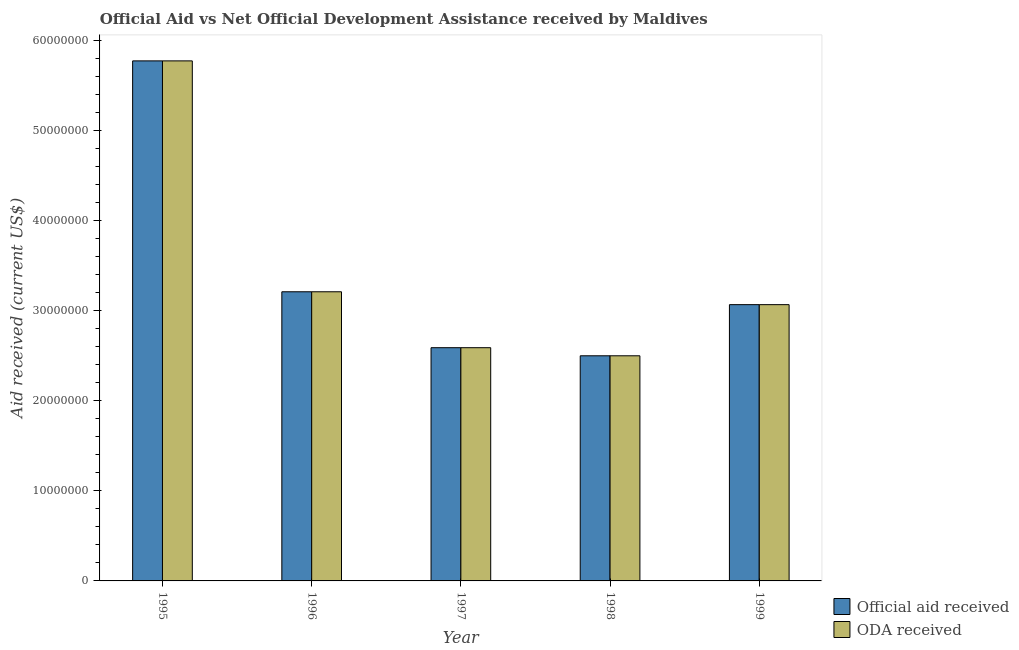How many groups of bars are there?
Offer a very short reply. 5. How many bars are there on the 3rd tick from the left?
Your answer should be compact. 2. What is the official aid received in 1995?
Keep it short and to the point. 5.78e+07. Across all years, what is the maximum oda received?
Give a very brief answer. 5.78e+07. Across all years, what is the minimum oda received?
Your answer should be compact. 2.50e+07. In which year was the oda received maximum?
Give a very brief answer. 1995. In which year was the oda received minimum?
Ensure brevity in your answer.  1998. What is the total oda received in the graph?
Give a very brief answer. 1.71e+08. What is the difference between the oda received in 1997 and that in 1998?
Your response must be concise. 9.00e+05. What is the difference between the official aid received in 1998 and the oda received in 1999?
Provide a short and direct response. -5.68e+06. What is the average oda received per year?
Provide a succinct answer. 3.43e+07. In the year 1999, what is the difference between the official aid received and oda received?
Offer a very short reply. 0. In how many years, is the oda received greater than 56000000 US$?
Ensure brevity in your answer.  1. What is the ratio of the official aid received in 1995 to that in 1997?
Keep it short and to the point. 2.23. Is the oda received in 1998 less than that in 1999?
Keep it short and to the point. Yes. What is the difference between the highest and the second highest official aid received?
Give a very brief answer. 2.56e+07. What is the difference between the highest and the lowest oda received?
Keep it short and to the point. 3.28e+07. In how many years, is the oda received greater than the average oda received taken over all years?
Keep it short and to the point. 1. What does the 2nd bar from the left in 1998 represents?
Offer a very short reply. ODA received. What does the 1st bar from the right in 1996 represents?
Make the answer very short. ODA received. How many bars are there?
Offer a very short reply. 10. Are the values on the major ticks of Y-axis written in scientific E-notation?
Keep it short and to the point. No. What is the title of the graph?
Your response must be concise. Official Aid vs Net Official Development Assistance received by Maldives . Does "Savings" appear as one of the legend labels in the graph?
Ensure brevity in your answer.  No. What is the label or title of the X-axis?
Your answer should be compact. Year. What is the label or title of the Y-axis?
Ensure brevity in your answer.  Aid received (current US$). What is the Aid received (current US$) of Official aid received in 1995?
Offer a terse response. 5.78e+07. What is the Aid received (current US$) in ODA received in 1995?
Your answer should be very brief. 5.78e+07. What is the Aid received (current US$) in Official aid received in 1996?
Provide a short and direct response. 3.21e+07. What is the Aid received (current US$) in ODA received in 1996?
Provide a short and direct response. 3.21e+07. What is the Aid received (current US$) of Official aid received in 1997?
Ensure brevity in your answer.  2.59e+07. What is the Aid received (current US$) in ODA received in 1997?
Your answer should be compact. 2.59e+07. What is the Aid received (current US$) in Official aid received in 1998?
Make the answer very short. 2.50e+07. What is the Aid received (current US$) of ODA received in 1998?
Provide a succinct answer. 2.50e+07. What is the Aid received (current US$) in Official aid received in 1999?
Your response must be concise. 3.07e+07. What is the Aid received (current US$) of ODA received in 1999?
Your answer should be very brief. 3.07e+07. Across all years, what is the maximum Aid received (current US$) in Official aid received?
Provide a short and direct response. 5.78e+07. Across all years, what is the maximum Aid received (current US$) in ODA received?
Make the answer very short. 5.78e+07. Across all years, what is the minimum Aid received (current US$) of Official aid received?
Your answer should be very brief. 2.50e+07. Across all years, what is the minimum Aid received (current US$) in ODA received?
Provide a short and direct response. 2.50e+07. What is the total Aid received (current US$) in Official aid received in the graph?
Keep it short and to the point. 1.71e+08. What is the total Aid received (current US$) of ODA received in the graph?
Provide a succinct answer. 1.71e+08. What is the difference between the Aid received (current US$) in Official aid received in 1995 and that in 1996?
Provide a succinct answer. 2.56e+07. What is the difference between the Aid received (current US$) of ODA received in 1995 and that in 1996?
Ensure brevity in your answer.  2.56e+07. What is the difference between the Aid received (current US$) in Official aid received in 1995 and that in 1997?
Offer a very short reply. 3.18e+07. What is the difference between the Aid received (current US$) in ODA received in 1995 and that in 1997?
Provide a short and direct response. 3.18e+07. What is the difference between the Aid received (current US$) in Official aid received in 1995 and that in 1998?
Provide a short and direct response. 3.28e+07. What is the difference between the Aid received (current US$) of ODA received in 1995 and that in 1998?
Offer a very short reply. 3.28e+07. What is the difference between the Aid received (current US$) in Official aid received in 1995 and that in 1999?
Your answer should be very brief. 2.71e+07. What is the difference between the Aid received (current US$) in ODA received in 1995 and that in 1999?
Make the answer very short. 2.71e+07. What is the difference between the Aid received (current US$) in Official aid received in 1996 and that in 1997?
Make the answer very short. 6.21e+06. What is the difference between the Aid received (current US$) of ODA received in 1996 and that in 1997?
Keep it short and to the point. 6.21e+06. What is the difference between the Aid received (current US$) in Official aid received in 1996 and that in 1998?
Give a very brief answer. 7.11e+06. What is the difference between the Aid received (current US$) in ODA received in 1996 and that in 1998?
Ensure brevity in your answer.  7.11e+06. What is the difference between the Aid received (current US$) of Official aid received in 1996 and that in 1999?
Give a very brief answer. 1.43e+06. What is the difference between the Aid received (current US$) of ODA received in 1996 and that in 1999?
Your response must be concise. 1.43e+06. What is the difference between the Aid received (current US$) of Official aid received in 1997 and that in 1998?
Your answer should be compact. 9.00e+05. What is the difference between the Aid received (current US$) of ODA received in 1997 and that in 1998?
Your answer should be compact. 9.00e+05. What is the difference between the Aid received (current US$) of Official aid received in 1997 and that in 1999?
Provide a succinct answer. -4.78e+06. What is the difference between the Aid received (current US$) of ODA received in 1997 and that in 1999?
Ensure brevity in your answer.  -4.78e+06. What is the difference between the Aid received (current US$) of Official aid received in 1998 and that in 1999?
Provide a succinct answer. -5.68e+06. What is the difference between the Aid received (current US$) of ODA received in 1998 and that in 1999?
Provide a short and direct response. -5.68e+06. What is the difference between the Aid received (current US$) in Official aid received in 1995 and the Aid received (current US$) in ODA received in 1996?
Make the answer very short. 2.56e+07. What is the difference between the Aid received (current US$) in Official aid received in 1995 and the Aid received (current US$) in ODA received in 1997?
Keep it short and to the point. 3.18e+07. What is the difference between the Aid received (current US$) in Official aid received in 1995 and the Aid received (current US$) in ODA received in 1998?
Provide a succinct answer. 3.28e+07. What is the difference between the Aid received (current US$) of Official aid received in 1995 and the Aid received (current US$) of ODA received in 1999?
Offer a very short reply. 2.71e+07. What is the difference between the Aid received (current US$) of Official aid received in 1996 and the Aid received (current US$) of ODA received in 1997?
Provide a short and direct response. 6.21e+06. What is the difference between the Aid received (current US$) of Official aid received in 1996 and the Aid received (current US$) of ODA received in 1998?
Give a very brief answer. 7.11e+06. What is the difference between the Aid received (current US$) of Official aid received in 1996 and the Aid received (current US$) of ODA received in 1999?
Your response must be concise. 1.43e+06. What is the difference between the Aid received (current US$) in Official aid received in 1997 and the Aid received (current US$) in ODA received in 1999?
Your answer should be compact. -4.78e+06. What is the difference between the Aid received (current US$) of Official aid received in 1998 and the Aid received (current US$) of ODA received in 1999?
Your answer should be very brief. -5.68e+06. What is the average Aid received (current US$) of Official aid received per year?
Your response must be concise. 3.43e+07. What is the average Aid received (current US$) in ODA received per year?
Provide a succinct answer. 3.43e+07. In the year 1997, what is the difference between the Aid received (current US$) of Official aid received and Aid received (current US$) of ODA received?
Your answer should be very brief. 0. In the year 1998, what is the difference between the Aid received (current US$) in Official aid received and Aid received (current US$) in ODA received?
Keep it short and to the point. 0. In the year 1999, what is the difference between the Aid received (current US$) of Official aid received and Aid received (current US$) of ODA received?
Make the answer very short. 0. What is the ratio of the Aid received (current US$) of Official aid received in 1995 to that in 1996?
Your answer should be compact. 1.8. What is the ratio of the Aid received (current US$) of ODA received in 1995 to that in 1996?
Provide a short and direct response. 1.8. What is the ratio of the Aid received (current US$) in Official aid received in 1995 to that in 1997?
Provide a short and direct response. 2.23. What is the ratio of the Aid received (current US$) in ODA received in 1995 to that in 1997?
Your response must be concise. 2.23. What is the ratio of the Aid received (current US$) in Official aid received in 1995 to that in 1998?
Your response must be concise. 2.31. What is the ratio of the Aid received (current US$) of ODA received in 1995 to that in 1998?
Provide a short and direct response. 2.31. What is the ratio of the Aid received (current US$) of Official aid received in 1995 to that in 1999?
Offer a terse response. 1.88. What is the ratio of the Aid received (current US$) of ODA received in 1995 to that in 1999?
Give a very brief answer. 1.88. What is the ratio of the Aid received (current US$) of Official aid received in 1996 to that in 1997?
Keep it short and to the point. 1.24. What is the ratio of the Aid received (current US$) in ODA received in 1996 to that in 1997?
Offer a very short reply. 1.24. What is the ratio of the Aid received (current US$) in Official aid received in 1996 to that in 1998?
Ensure brevity in your answer.  1.28. What is the ratio of the Aid received (current US$) in ODA received in 1996 to that in 1998?
Provide a short and direct response. 1.28. What is the ratio of the Aid received (current US$) in Official aid received in 1996 to that in 1999?
Keep it short and to the point. 1.05. What is the ratio of the Aid received (current US$) in ODA received in 1996 to that in 1999?
Offer a terse response. 1.05. What is the ratio of the Aid received (current US$) in Official aid received in 1997 to that in 1998?
Keep it short and to the point. 1.04. What is the ratio of the Aid received (current US$) of ODA received in 1997 to that in 1998?
Provide a short and direct response. 1.04. What is the ratio of the Aid received (current US$) of Official aid received in 1997 to that in 1999?
Offer a terse response. 0.84. What is the ratio of the Aid received (current US$) of ODA received in 1997 to that in 1999?
Keep it short and to the point. 0.84. What is the ratio of the Aid received (current US$) in Official aid received in 1998 to that in 1999?
Offer a very short reply. 0.81. What is the ratio of the Aid received (current US$) of ODA received in 1998 to that in 1999?
Offer a very short reply. 0.81. What is the difference between the highest and the second highest Aid received (current US$) in Official aid received?
Offer a terse response. 2.56e+07. What is the difference between the highest and the second highest Aid received (current US$) of ODA received?
Provide a succinct answer. 2.56e+07. What is the difference between the highest and the lowest Aid received (current US$) in Official aid received?
Your answer should be compact. 3.28e+07. What is the difference between the highest and the lowest Aid received (current US$) of ODA received?
Your answer should be compact. 3.28e+07. 